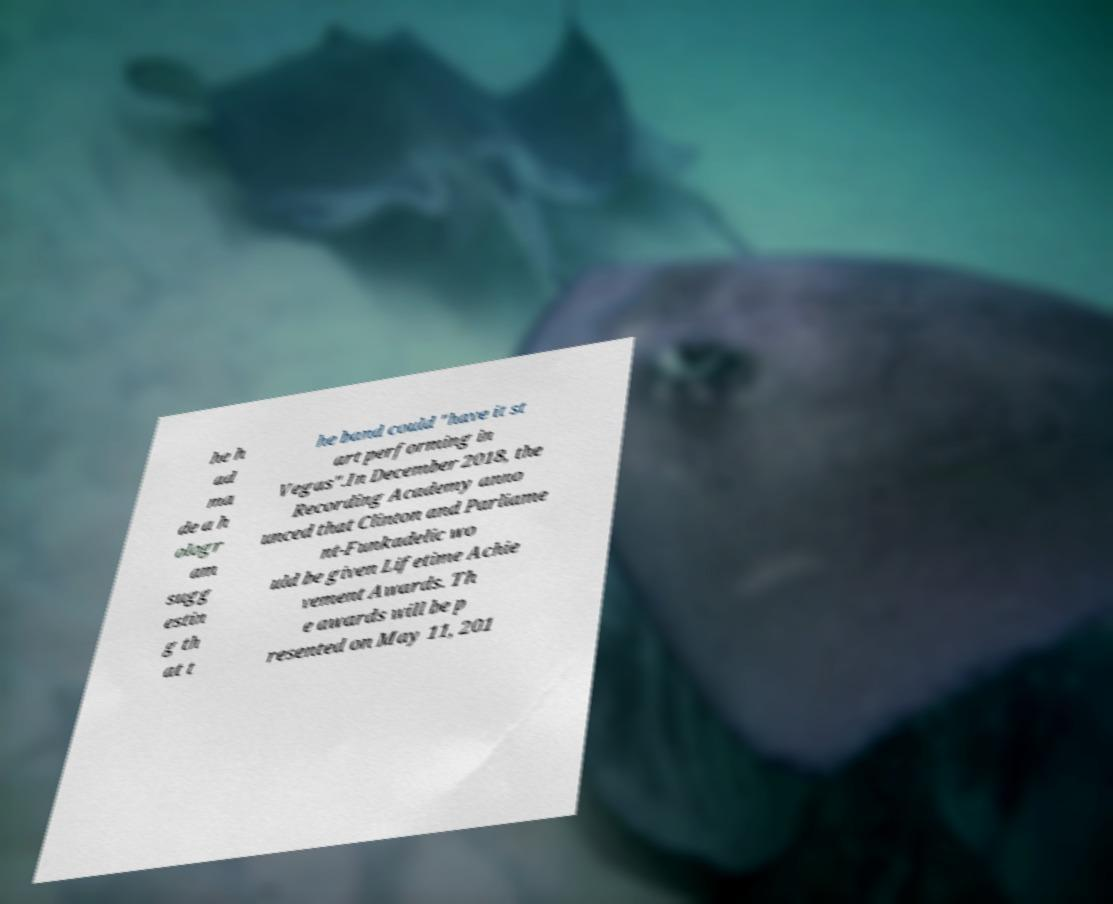For documentation purposes, I need the text within this image transcribed. Could you provide that? he h ad ma de a h ologr am sugg estin g th at t he band could "have it st art performing in Vegas".In December 2018, the Recording Academy anno unced that Clinton and Parliame nt-Funkadelic wo uld be given Lifetime Achie vement Awards. Th e awards will be p resented on May 11, 201 